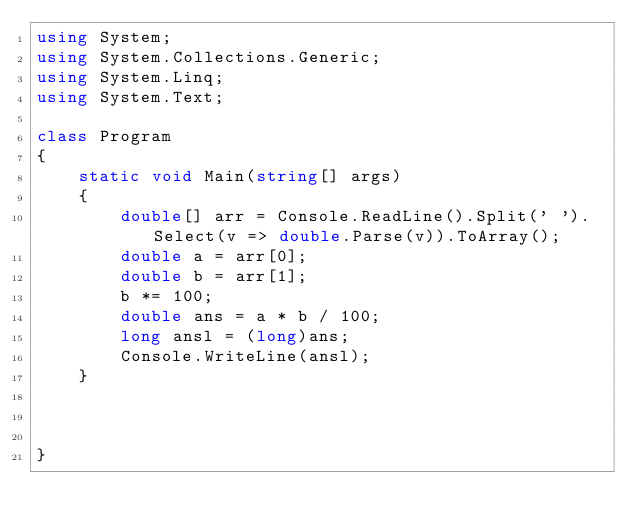<code> <loc_0><loc_0><loc_500><loc_500><_C#_>using System;
using System.Collections.Generic;
using System.Linq;
using System.Text;

class Program
{
    static void Main(string[] args)
    {
        double[] arr = Console.ReadLine().Split(' ').Select(v => double.Parse(v)).ToArray();
        double a = arr[0];
        double b = arr[1];
        b *= 100;
        double ans = a * b / 100;
        long ansl = (long)ans;
        Console.WriteLine(ansl);
    }

   

}


</code> 